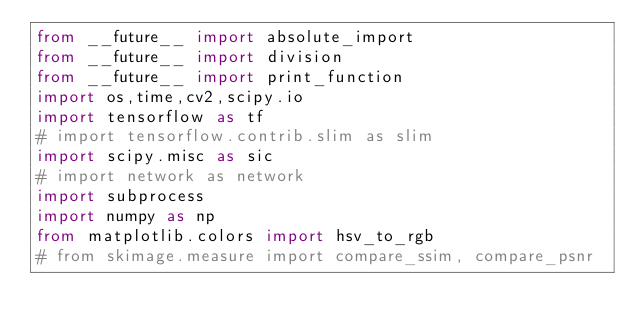Convert code to text. <code><loc_0><loc_0><loc_500><loc_500><_Python_>from __future__ import absolute_import
from __future__ import division
from __future__ import print_function
import os,time,cv2,scipy.io
import tensorflow as tf
# import tensorflow.contrib.slim as slim
import scipy.misc as sic
# import network as network
import subprocess
import numpy as np
from matplotlib.colors import hsv_to_rgb
# from skimage.measure import compare_ssim, compare_psnr</code> 